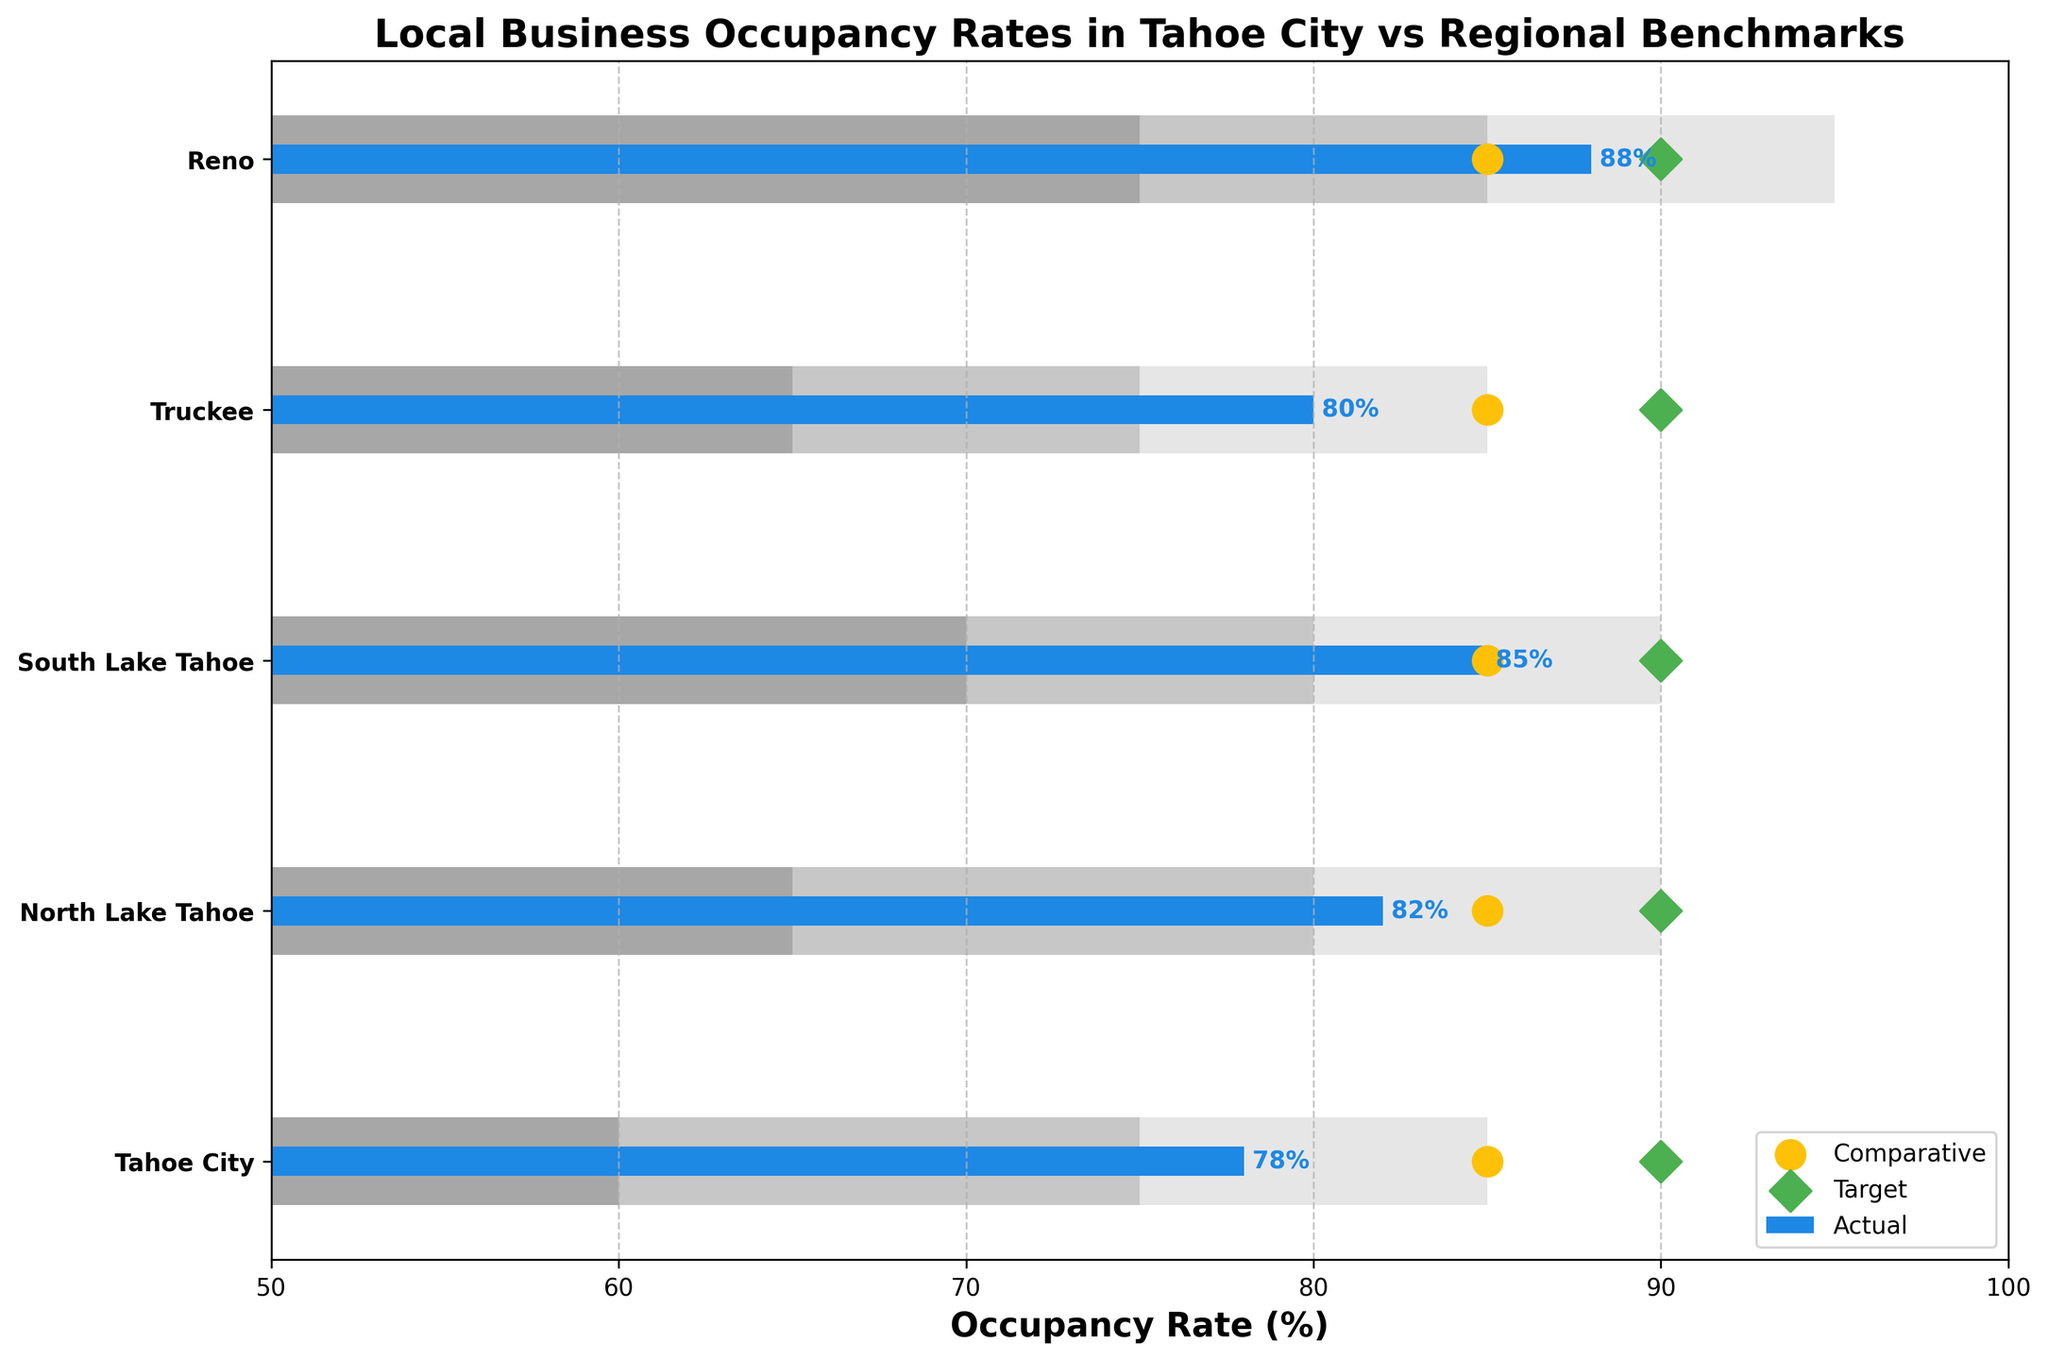What's the title of the chart? The title of the chart is located at the top and is clearly visible. It reads, "Local Business Occupancy Rates in Tahoe City vs Regional Benchmarks."
Answer: Local Business Occupancy Rates in Tahoe City vs Regional Benchmarks What is the occupancy rate for South Lake Tahoe? The occupancy rate for South Lake Tahoe can be identified by looking at the bar corresponding to South Lake Tahoe. The height of the bar indicates the actual value, which is clearly labeled at the end of the bar.
Answer: 85% Which region has the highest actual occupancy rate? Among the bars for each region, the tallest one corresponds to Reno, which is labeled with an actual occupancy rate. The label on this bar shows 88%.
Answer: Reno What is the difference between Tahoe City's actual occupancy rate and its target occupancy rate? The actual occupancy rate for Tahoe City is 78%, and the target occupancy rate is 90%. The difference between these two values is 90% - 78% = 12%.
Answer: 12% How does Tahoe City's actual occupancy rate compare to the comparative benchmark? Tahoe City's actual occupancy rate is 78%, while the comparative benchmark is shown as a marker at 85%. Therefore, Tahoe City's rate is 7% lower than the comparative benchmark.
Answer: 7% lower Which regions have an actual occupancy rate that is below their respective comparative benchmarks? By comparing the bars and the comparative benchmark markers, Tahoe City and Truckee both have actual occupancy rates below their comparative benchmarks (78% vs. 85% and 80% vs. 85%, respectively).
Answer: Tahoe City, Truckee Is Tahoe City meeting its target occupancy rate? The target occupancy rate for Tahoe City is indicated by a marker at 90%. The actual occupancy rate is 78%. Since 78% is less than 90%, Tahoe City is not meeting its target occupancy rate.
Answer: No How many regions have actual occupancy rates within the range of 80% to 90%? By examining the bars, North Lake Tahoe (82%), South Lake Tahoe (85%), and Truckee (80%) fall within the range of 80% to 90%.
Answer: 3 What color represents the actual occupancy rates, and what color represents the comparative benchmarks? The bars corresponding to actual occupancy rates are colored in blue while the comparative benchmark markers are in yellow.
Answer: Blue for actual, Yellow for comparative 